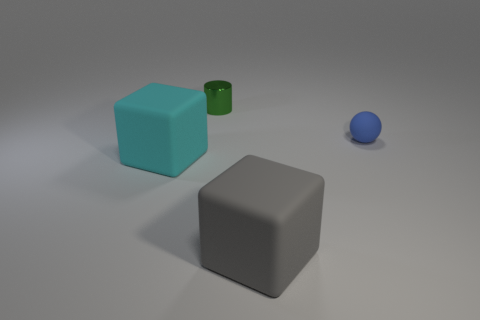Add 3 blue objects. How many objects exist? 7 Subtract 1 cylinders. How many cylinders are left? 0 Subtract all spheres. How many objects are left? 3 Subtract all cyan cubes. How many cubes are left? 1 Subtract all yellow balls. Subtract all brown cubes. How many balls are left? 1 Add 2 large green things. How many large green things exist? 2 Subtract 0 blue cubes. How many objects are left? 4 Subtract all cyan balls. How many blue cubes are left? 0 Subtract all tiny blue matte cylinders. Subtract all small green metallic objects. How many objects are left? 3 Add 3 matte objects. How many matte objects are left? 6 